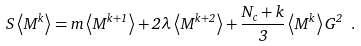Convert formula to latex. <formula><loc_0><loc_0><loc_500><loc_500>S \left < M ^ { k } \right > = m \left < M ^ { k + 1 } \right > + 2 \lambda \left < M ^ { k + 2 } \right > + \frac { N _ { c } + k } { 3 } \left < M ^ { k } \right > G ^ { 2 } \ .</formula> 